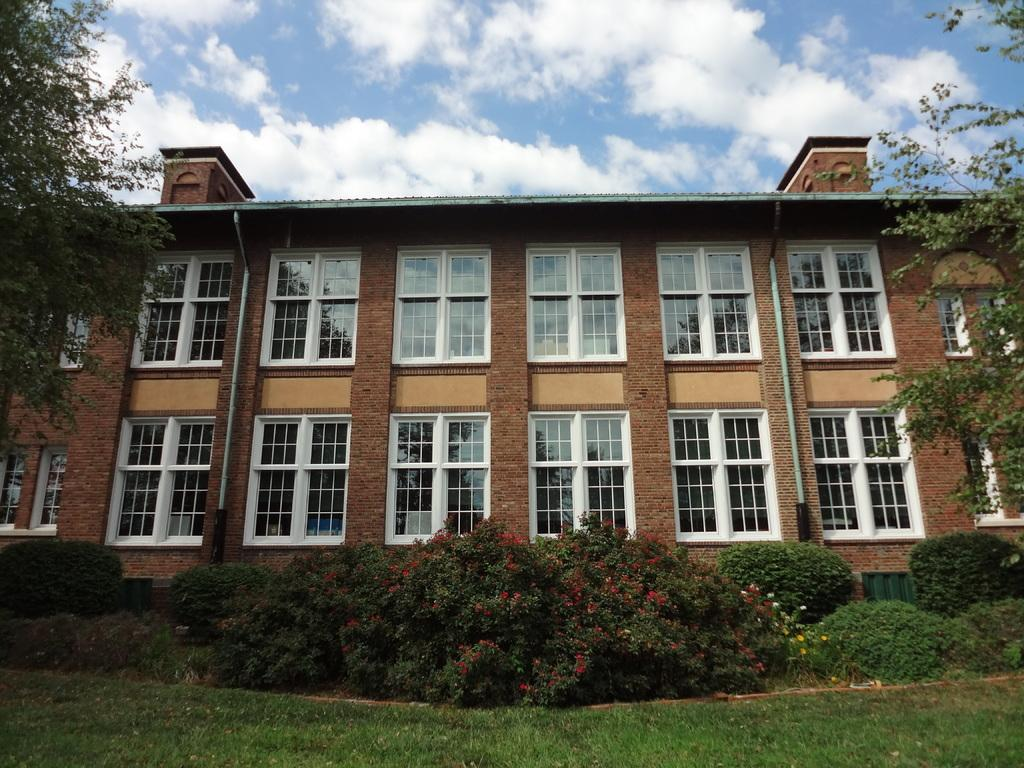What type of structure is visible in the image? There is a building with windows in the image. What is located in front of the building? There are plants, grass, and trees in front of the building. What can be seen in the background of the image? The sky is visible in the background of the image. What is the condition of the sky in the image? There are clouds in the sky in the image. What invention is being demonstrated in the image? There is no invention being demonstrated in the image; it features a building with windows and natural elements in front of it. What is the fear that the plants in the image are experiencing? Plants do not experience fear, so this question cannot be answered. 